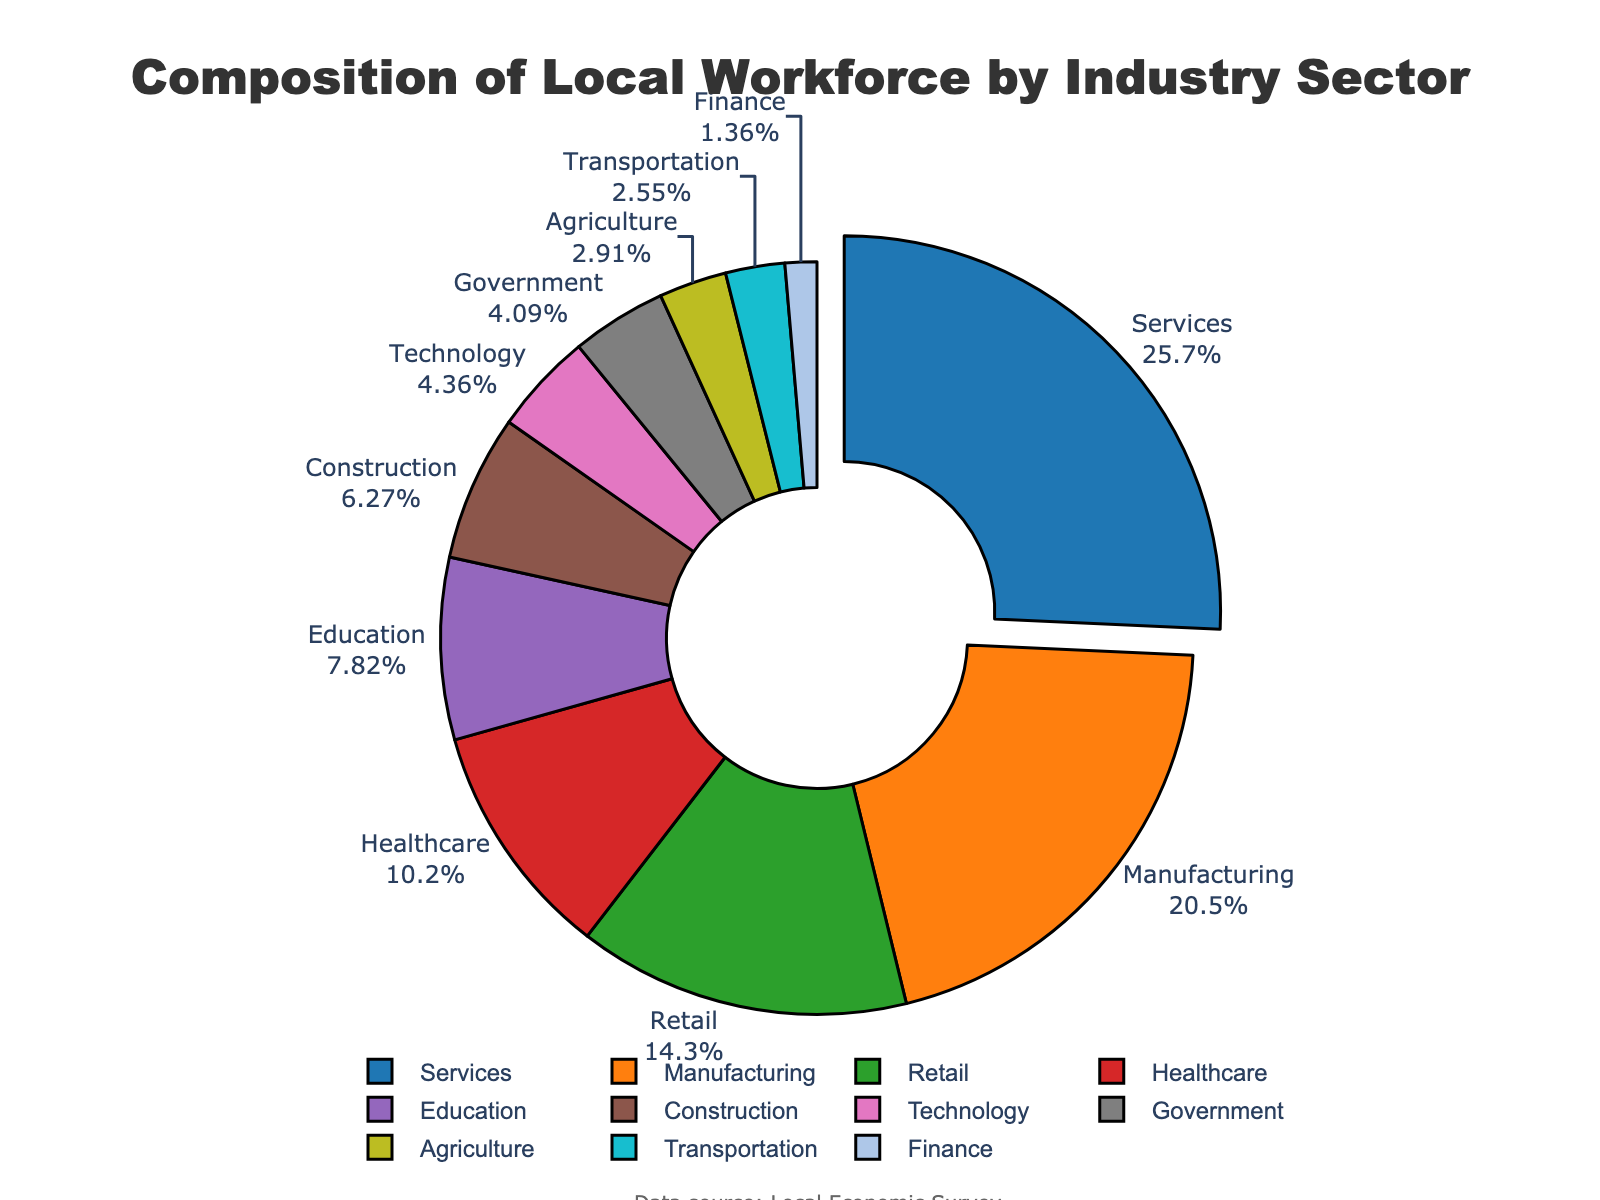Which industry sector has the largest share of the local workforce? The visual size of the 'Services' slice is the largest and it is also listed at the top with the pulled-out segment, indicating it has the largest percentage.
Answer: Services How many industry sectors make up over 10% of the local workforce? From the pie chart, we can see that Manufacturing (22.5%), Services (28.3%), Retail (15.7%), and Healthcare (11.2%) all have percentages above 10%.
Answer: 4 What is the combined percentage of the Education and Technology sectors? The percentage of the Education sector is 8.6% and the Technology sector is 4.8%. Adding these together: 8.6% + 4.8% = 13.4%.
Answer: 13.4% Which sector has a larger share: Construction or Government? By visually comparing the sizes of the slices, we can see that the Construction sector has a percentage of 6.9%, which is larger than the Government sector's 4.5%.
Answer: Construction What is the difference in workforce percentage between Retail and Healthcare? The percentage for Retail is 15.7% and for Healthcare is 11.2%. The difference between them is: 15.7% - 11.2% = 4.5%.
Answer: 4.5% What are the three smallest sectors by workforce percentage? The three smallest slices representing Agriculture (3.2%), Transportation (2.8%), and Finance (1.5%) can be seen visually in the pie chart, indicating they are the smallest.
Answer: Agriculture, Transportation, Finance Is the Healthcare sector larger or smaller than the Education sector? By comparing the two sectors, Healthcare is 11.2% and Education is 8.6%. Thus, Healthcare is larger than Education.
Answer: Larger What is the total percentage of the top three sectors combined? The top three sectors by percentage are Services (28.3%), Manufacturing (22.5%), and Retail (15.7%). Adding them together: 28.3% + 22.5% + 15.7% = 66.5%.
Answer: 66.5% Which sector is depicted with a color closest to red? Among the sectors and their colors, Retail is represented with a color that is closest to red.
Answer: Retail By how much does the share of the Manufacturing sector exceed the Government sector? Manufacturing holds 22.5% and Government holds 4.5%. The difference is: 22.5% - 4.5% = 18%.
Answer: 18% 